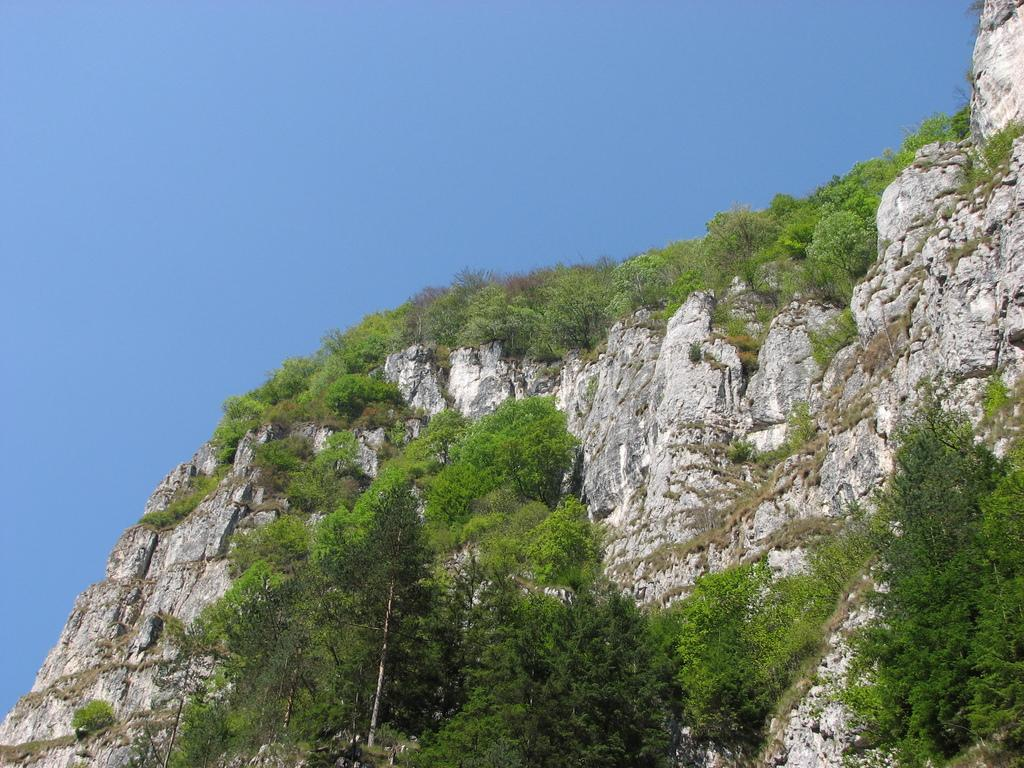What is located in the center of the image? There are trees in the center of the image. What can be seen in the background of the image? There is a hill and the sky visible in the background of the image. How many crates are stacked on top of each other in the image? There are no crates present in the image. What type of cable can be seen connecting the trees in the image? There is no cable connecting the trees in the image; the trees are not connected by any visible cables. 